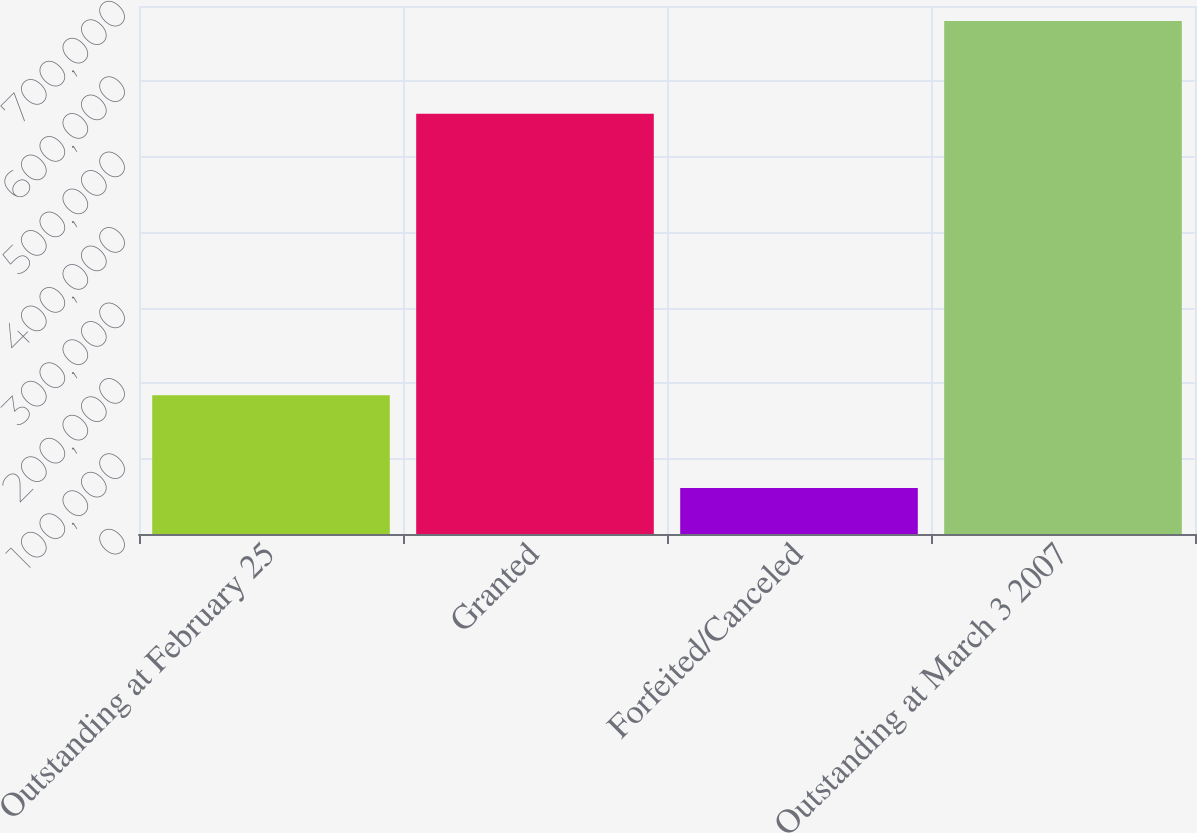<chart> <loc_0><loc_0><loc_500><loc_500><bar_chart><fcel>Outstanding at February 25<fcel>Granted<fcel>Forfeited/Canceled<fcel>Outstanding at March 3 2007<nl><fcel>184000<fcel>557000<fcel>61000<fcel>680000<nl></chart> 